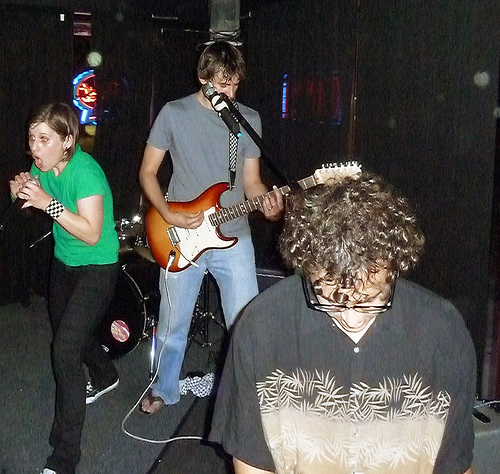<image>
Can you confirm if the curtain is behind the glasses? Yes. From this viewpoint, the curtain is positioned behind the glasses, with the glasses partially or fully occluding the curtain. Is the drum behind the woman? Yes. From this viewpoint, the drum is positioned behind the woman, with the woman partially or fully occluding the drum. 